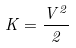Convert formula to latex. <formula><loc_0><loc_0><loc_500><loc_500>K = \frac { V ^ { 2 } } { 2 }</formula> 